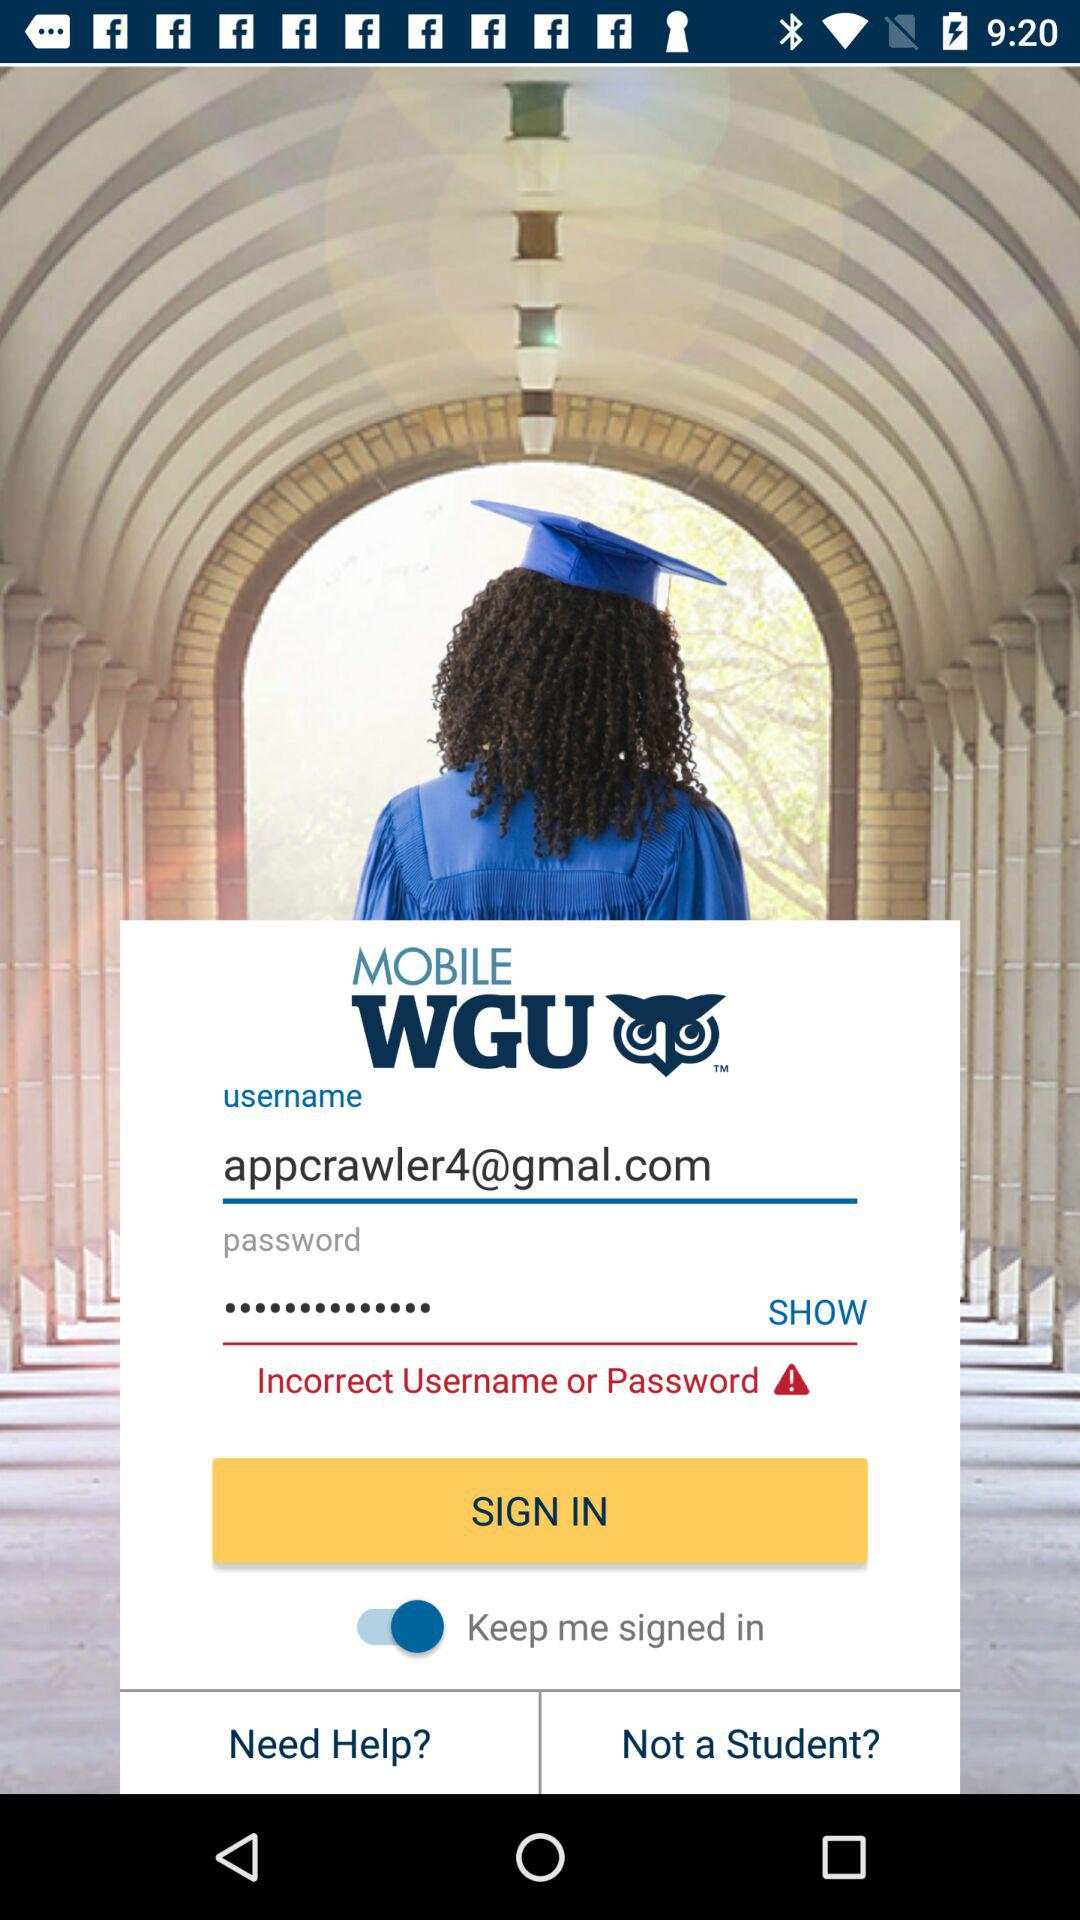What is the status of "Keep me signed in"? The status of "Keep me signed in" is "on". 